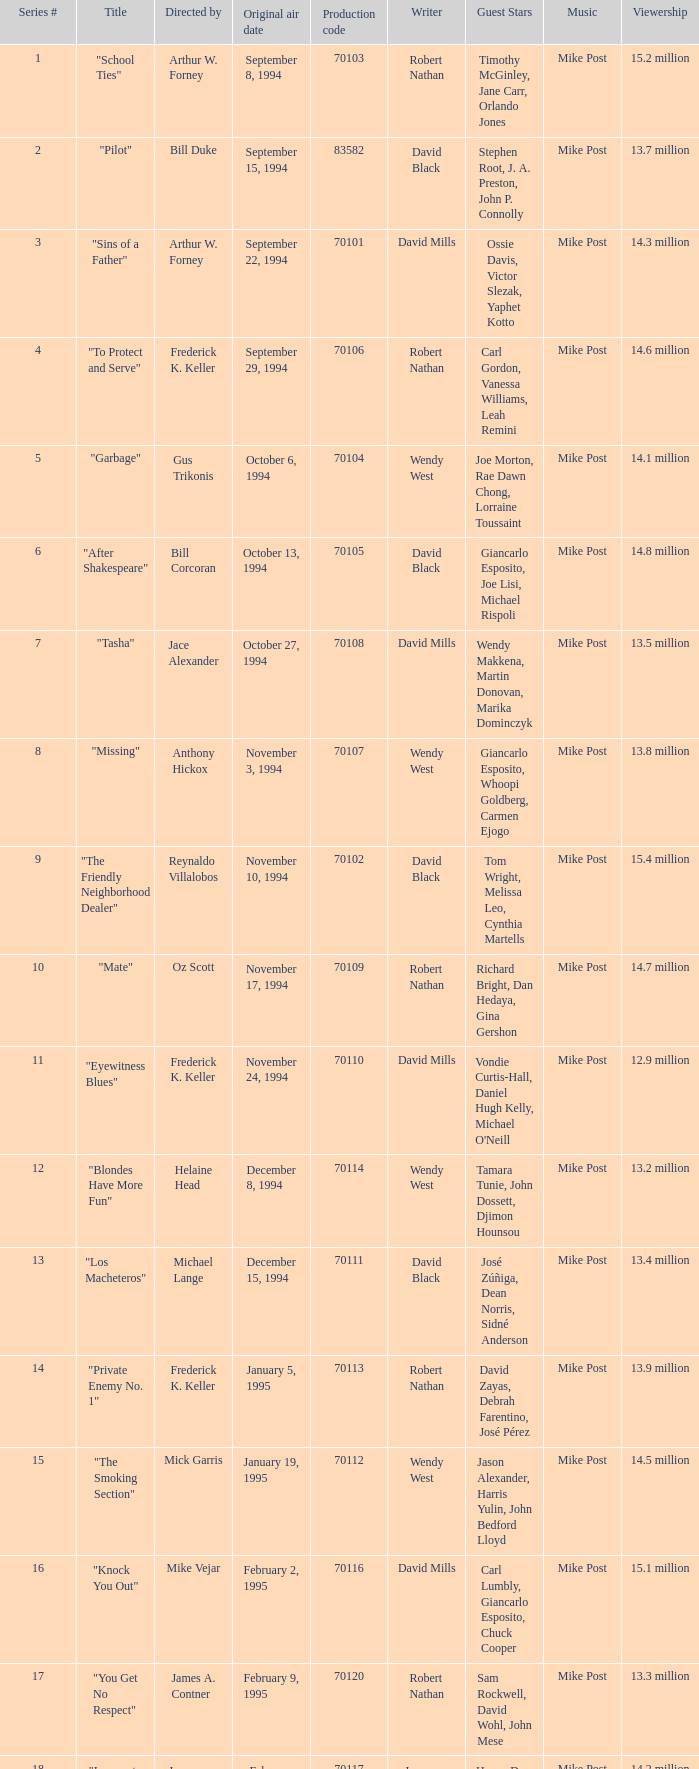What was the lowest production code value in series #10? 70109.0. 